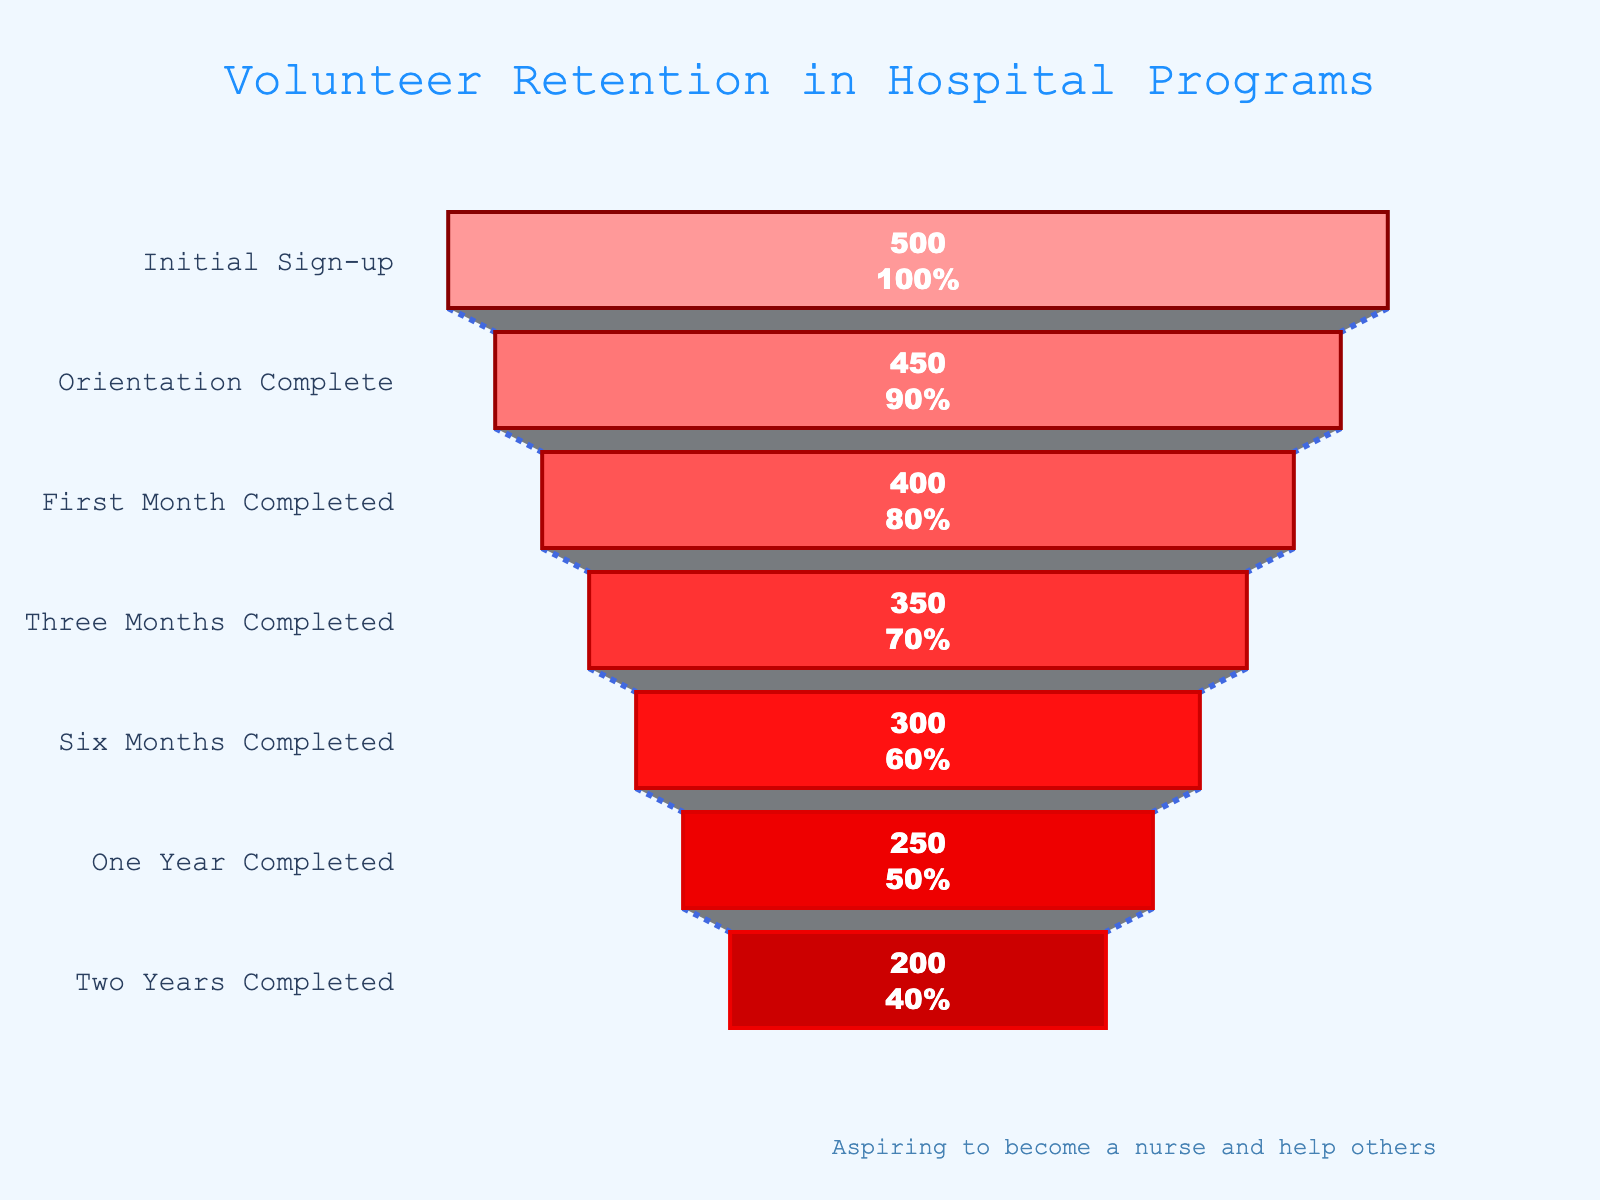what is the title of the chart? The title is located at the top center of the chart, which gives an overview of the data being represented. In this case, the title is "Volunteer Retention in Hospital Programs".
Answer: Volunteer Retention in Hospital Programs How many volunteers completed the orientation stage? To find the number of volunteers who completed the orientation stage, look at the "Orientation Complete" stage in the funnel chart. The volunteer count for this stage is displayed next to it.
Answer: 450 What percentage of initial volunteers stayed through to the end of the first month? Refer to the "First Month Completed" stage in the chart and compare it with the "Initial Sign-up" stage. The percentage is calculated based on the number of volunteers at these stages. 400 out of the initial 500 volunteers stayed, so the retention rate is \( (400/500) \times 100 \% \).
Answer: 80% How many volunteers remained after six months compared to those who signed up initially? The number of volunteers remaining after six months is shown next to the "Six Months Completed" stage. The initial number of volunteers is displayed next to the "Initial Sign-up" stage. Subtract the former from the latter to find the difference (500 - 300).
Answer: 200 What is the retention rate from the three-month mark to the six-month mark? Look at the number of volunteers at the "Three Months Completed" and "Six Months Completed" stages. The number at three months is 350, and at six months, it is 300. The retention rate is calculated as \( (300/350) \times 100 \% \).
Answer: 85.71% Which stage saw the largest drop in the number of volunteers? To determine this, analyze the decline in volunteers between each consecutive stage. Calculate the difference in volunteer numbers between each stage and identify the highest drop. The stages showing the most significant reduction are observed between "One Year Completed" (250) and "Six Months Completed" (300).
Answer: Between Six Months Completed and One Year Completed What is the retention rate from one year to two years? The number of volunteers at the one-year mark is 250, and at the two-year mark is 200. The retention rate from one year to two years is calculated as \( (200/250) \times 100 \% \).
Answer: 80% Is the decrease in the number of volunteers consistent across each stage? Examine the chart to see if the reduction in volunteer numbers is uniform across each stage. Assess the numerical differences between each stage transition. There are fluctuating retention rates indicating inconsistent decreases.
Answer: No What can be inferred about the long-term commitment of volunteers? Based on the chart, retention decreases consistently over time, indicating that a significant percentage of volunteers do not stay for longer periods. This might imply challenges in maintaining long-term commitment.
Answer: Decreases over time indicating challenges in long-term commitment In which stage do volunteers have the highest retention rate? To find out which stage has the highest retention rate, check the retention rate displayed next to each stage. The highest retention rate is observed in the transition from "Initial Sign-up" to "Orientation Complete", which is 90%.
Answer: Initial Sign-up to Orientation Complete 